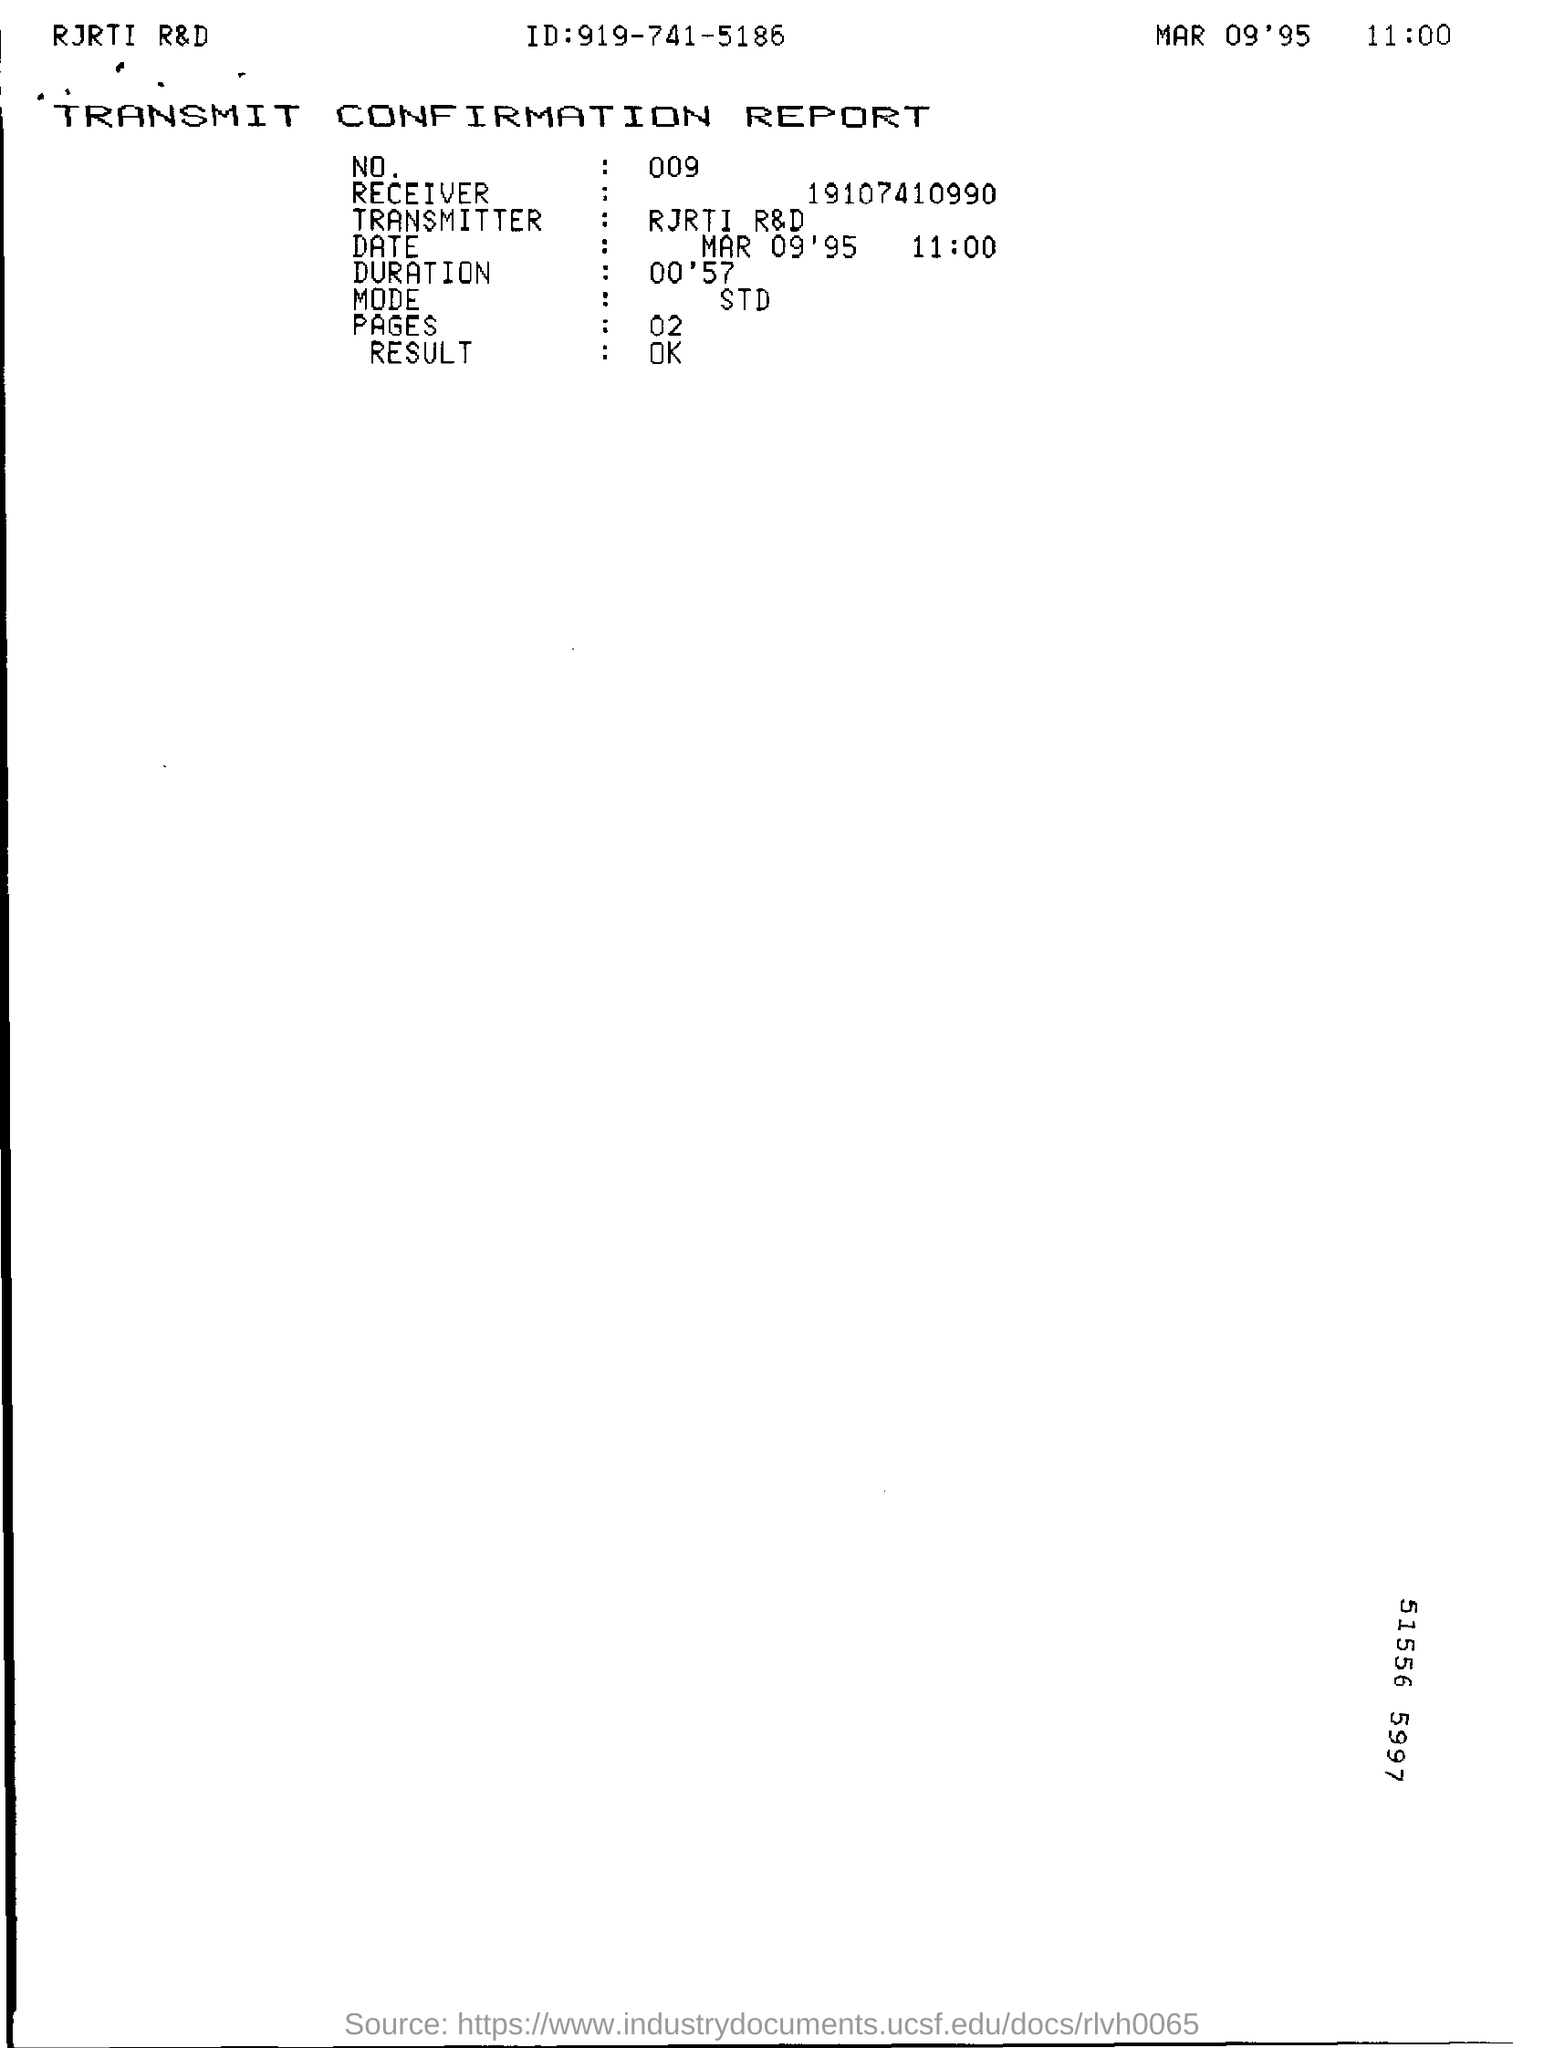What is the time in the document ?
Provide a succinct answer. 11:00. What is the name of the document ?
Provide a succinct answer. Transmit confirmation report. 